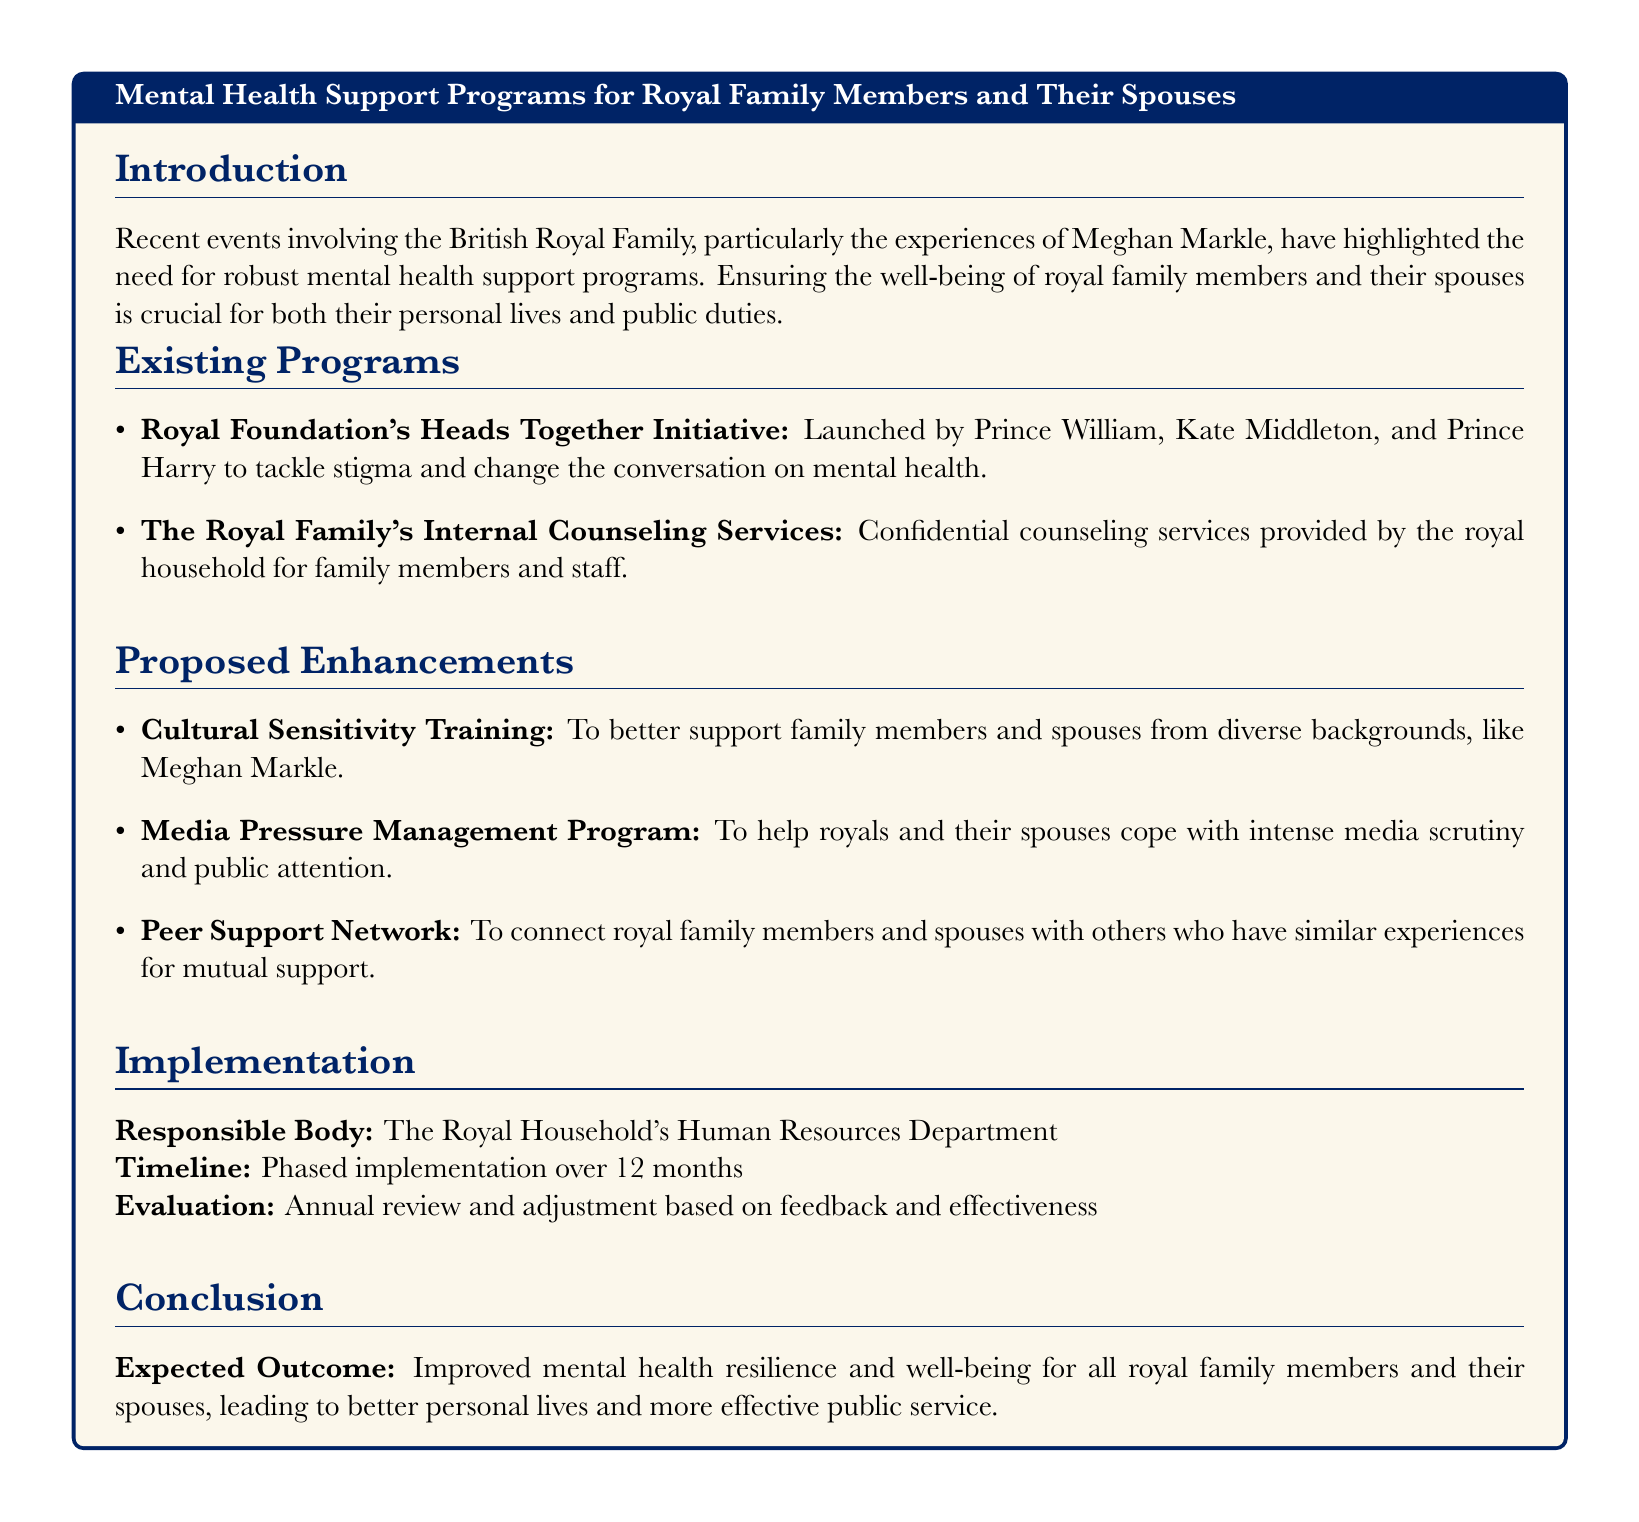What initiative was launched by Prince William, Kate Middleton, and Prince Harry? The initiative is aimed at tackling stigma and changing the conversation on mental health, which is the Royal Foundation's Heads Together Initiative.
Answer: Heads Together Initiative What program is proposed to support family members and spouses from diverse backgrounds? The document suggests enhancing support through Cultural Sensitivity Training, addressing the specific needs of individuals like Meghan Markle.
Answer: Cultural Sensitivity Training What is the responsible body for implementing the proposed mental health support programs? The implementation of the programs falls under the purview of the Royal Household's Human Resources Department as stated in the document.
Answer: Royal Household's Human Resources Department What is the expected outcome of the mental health support programs? The document outlines that the expected outcome is improved mental health resilience and well-being, which is crucial for their personal lives and effective public service.
Answer: Improved mental health resilience and well-being How long is the planned timeline for the phased implementation of the programs? The document specifies that the implementation is planned over a period of 12 months.
Answer: 12 months 